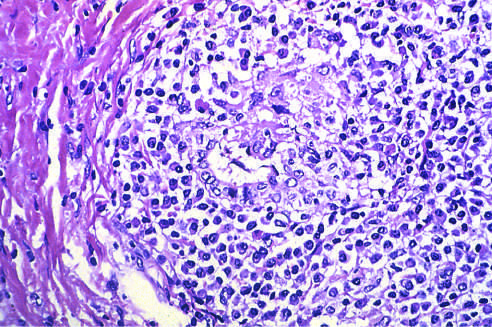what is markedly expanded by an infiltrate of lymphocytes and plasma cells?
Answer the question using a single word or phrase. A portal tract 